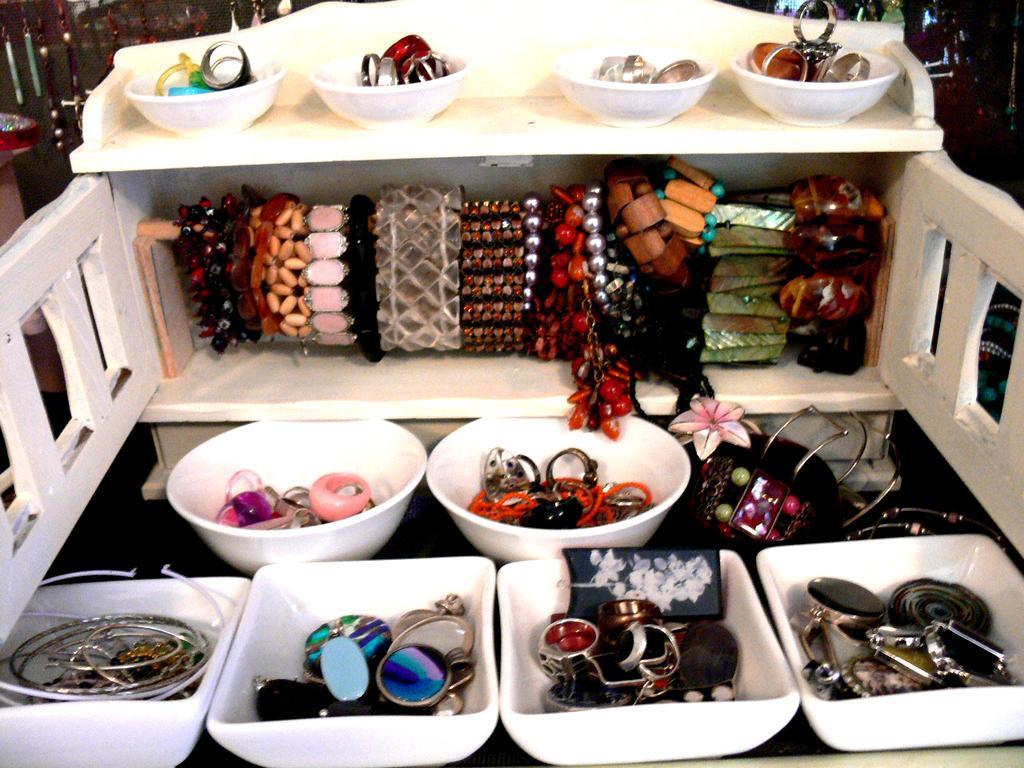In one or two sentences, can you explain what this image depicts? In the picture I can see objects in bowls and some other objects. These bowls are white in color. 